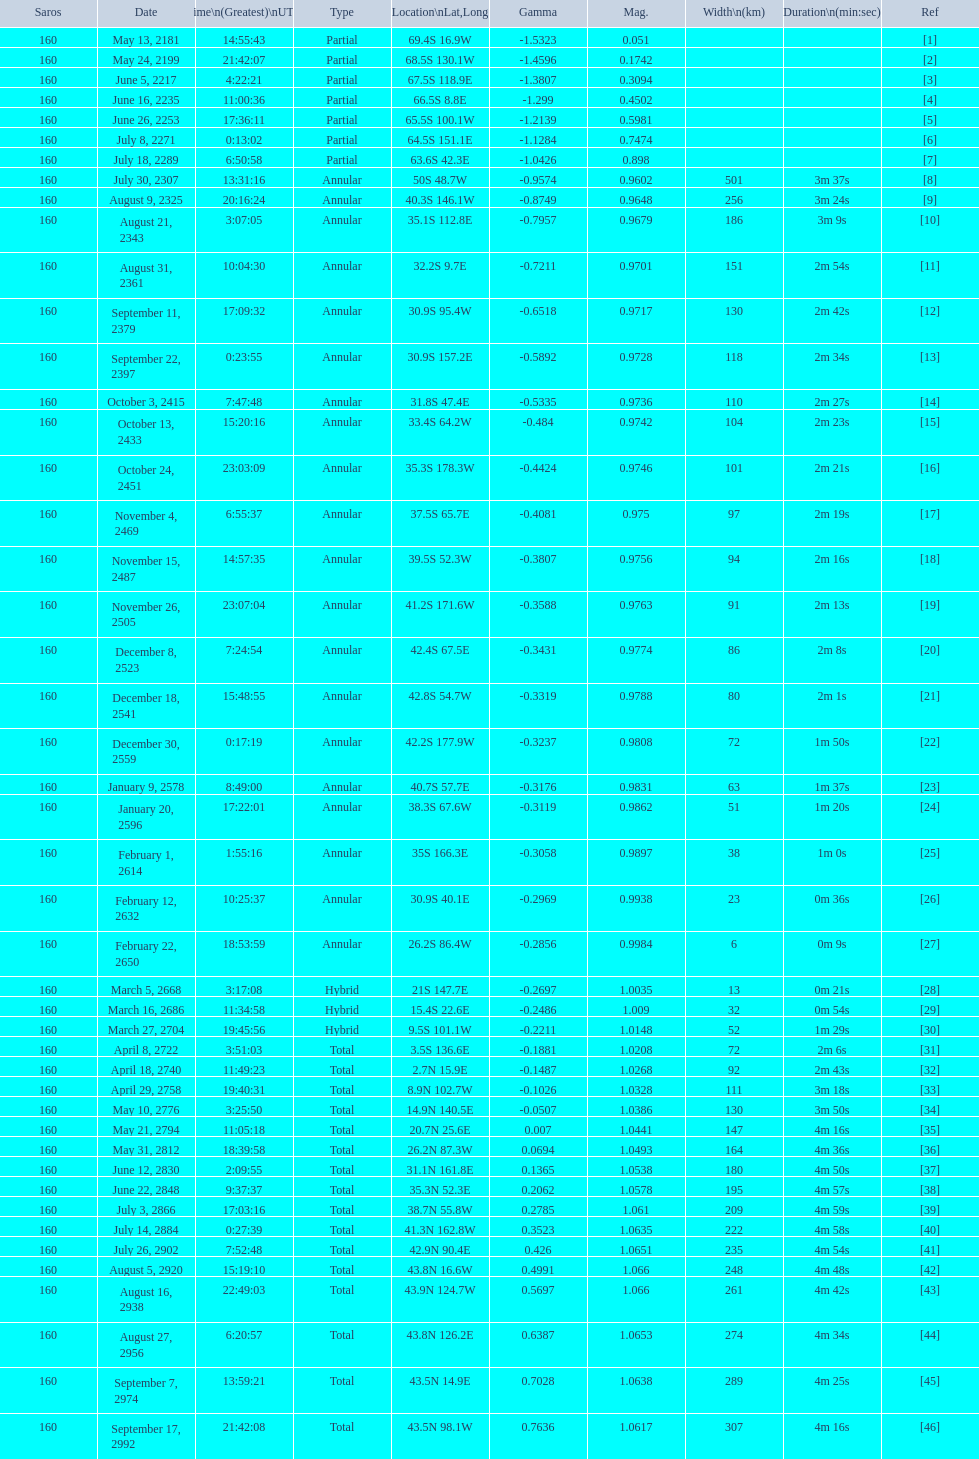In all, how many events will transpire? 46. 